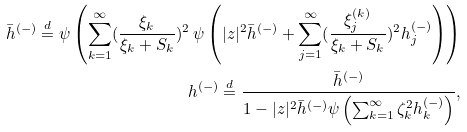Convert formula to latex. <formula><loc_0><loc_0><loc_500><loc_500>\bar { h } ^ { ( - ) } \stackrel { d } { = } \psi \left ( \sum _ { k = 1 } ^ { \infty } ( \frac { \xi _ { k } } { \xi _ { k } + S _ { k } } ) ^ { 2 } \, \psi \left ( | z | ^ { 2 } \bar { h } ^ { ( - ) } + \sum _ { j = 1 } ^ { \infty } ( \frac { \xi ^ { ( k ) } _ { j } } { \xi _ { k } + S _ { k } } ) ^ { 2 } h _ { j } ^ { ( - ) } \right ) \right ) \\ h ^ { ( - ) } \stackrel { d } { = } \frac { \bar { h } ^ { ( - ) } } { 1 - | z | ^ { 2 } \bar { h } ^ { ( - ) } \psi \left ( \sum _ { k = 1 } ^ { \infty } \zeta _ { k } ^ { 2 } h _ { k } ^ { ( - ) } \right ) } ,</formula> 